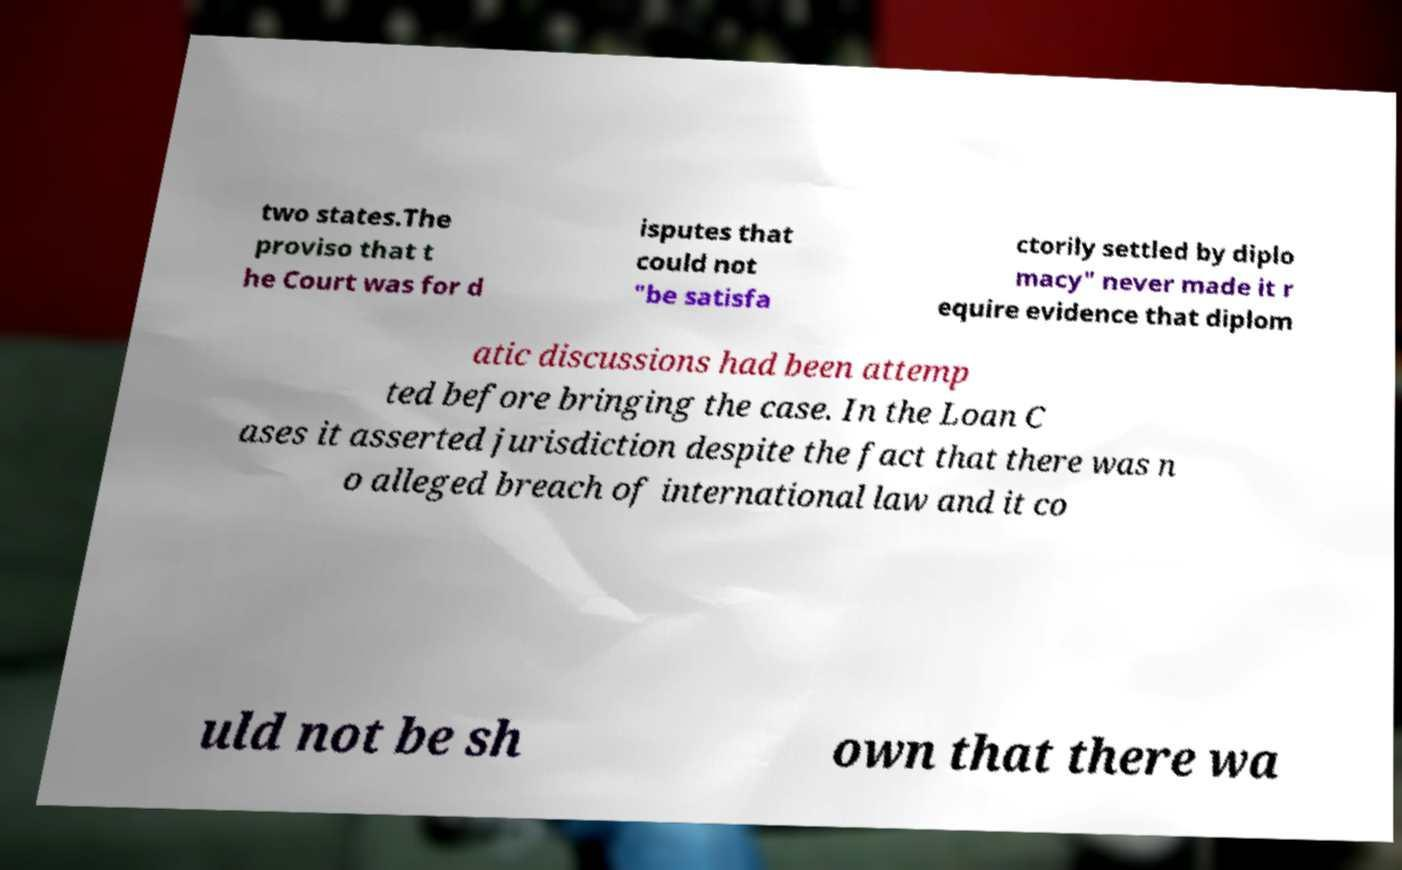I need the written content from this picture converted into text. Can you do that? two states.The proviso that t he Court was for d isputes that could not "be satisfa ctorily settled by diplo macy" never made it r equire evidence that diplom atic discussions had been attemp ted before bringing the case. In the Loan C ases it asserted jurisdiction despite the fact that there was n o alleged breach of international law and it co uld not be sh own that there wa 